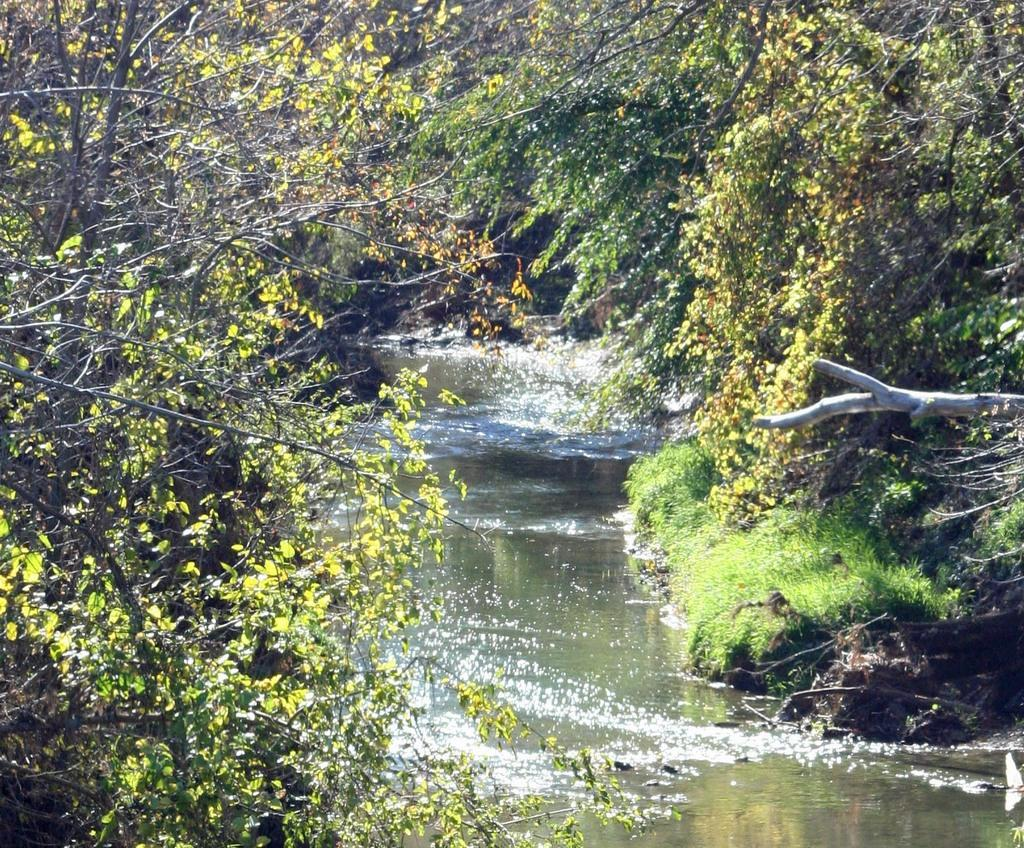What is visible in the image? Water is visible in the image. What can be seen on the left side of the image? There are trees on the left side of the image. What can be seen on the right side of the image? There are trees on the right side of the image. How does the hydrant contribute to the water in the image? There is no hydrant present in the image. 